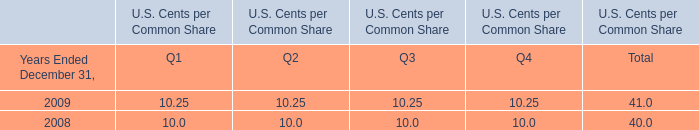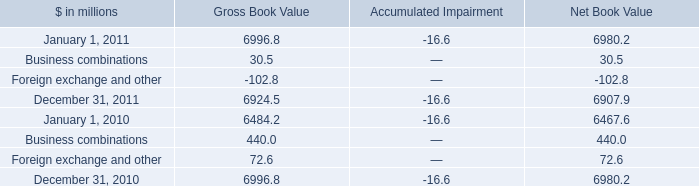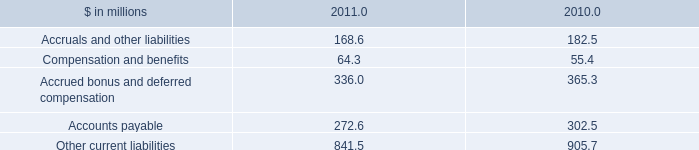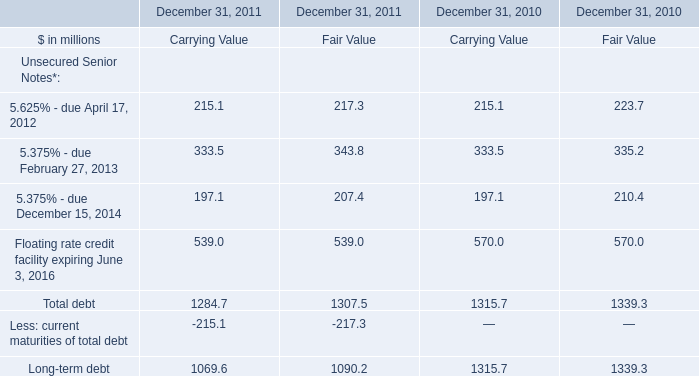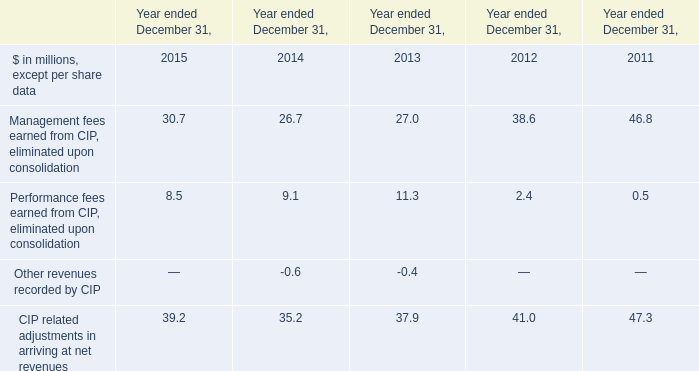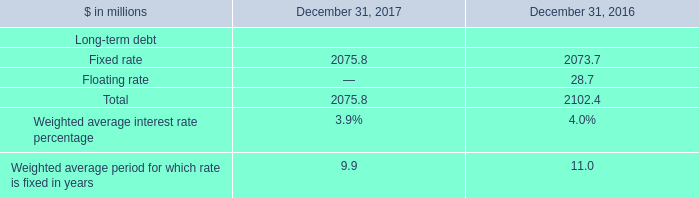In the year with largest amount of 5.625% - due April 17, 2012 what's the sum of 5.375% - due February 27, 2013? (in million) 
Computations: (333.5 + 335.2)
Answer: 668.7. 